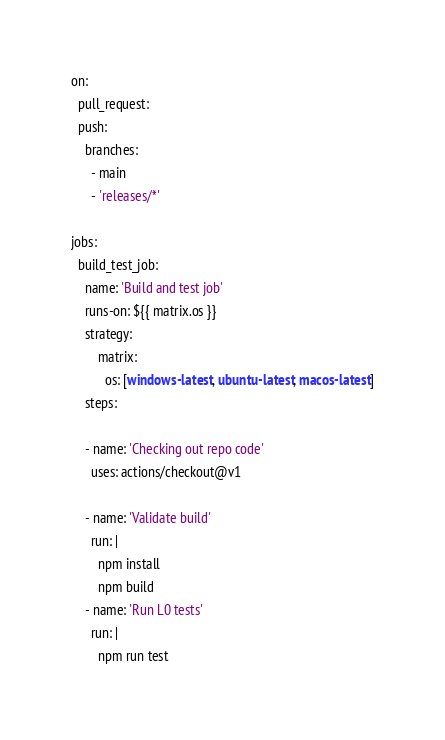<code> <loc_0><loc_0><loc_500><loc_500><_YAML_>on:
  pull_request:
  push:
    branches:
      - main
      - 'releases/*'

jobs:
  build_test_job:
    name: 'Build and test job'
    runs-on: ${{ matrix.os }}
    strategy:
        matrix:
          os: [windows-latest, ubuntu-latest, macos-latest]
    steps:

    - name: 'Checking out repo code'
      uses: actions/checkout@v1

    - name: 'Validate build'
      run: |
        npm install
        npm build
    - name: 'Run L0 tests'
      run: |
        npm run test</code> 